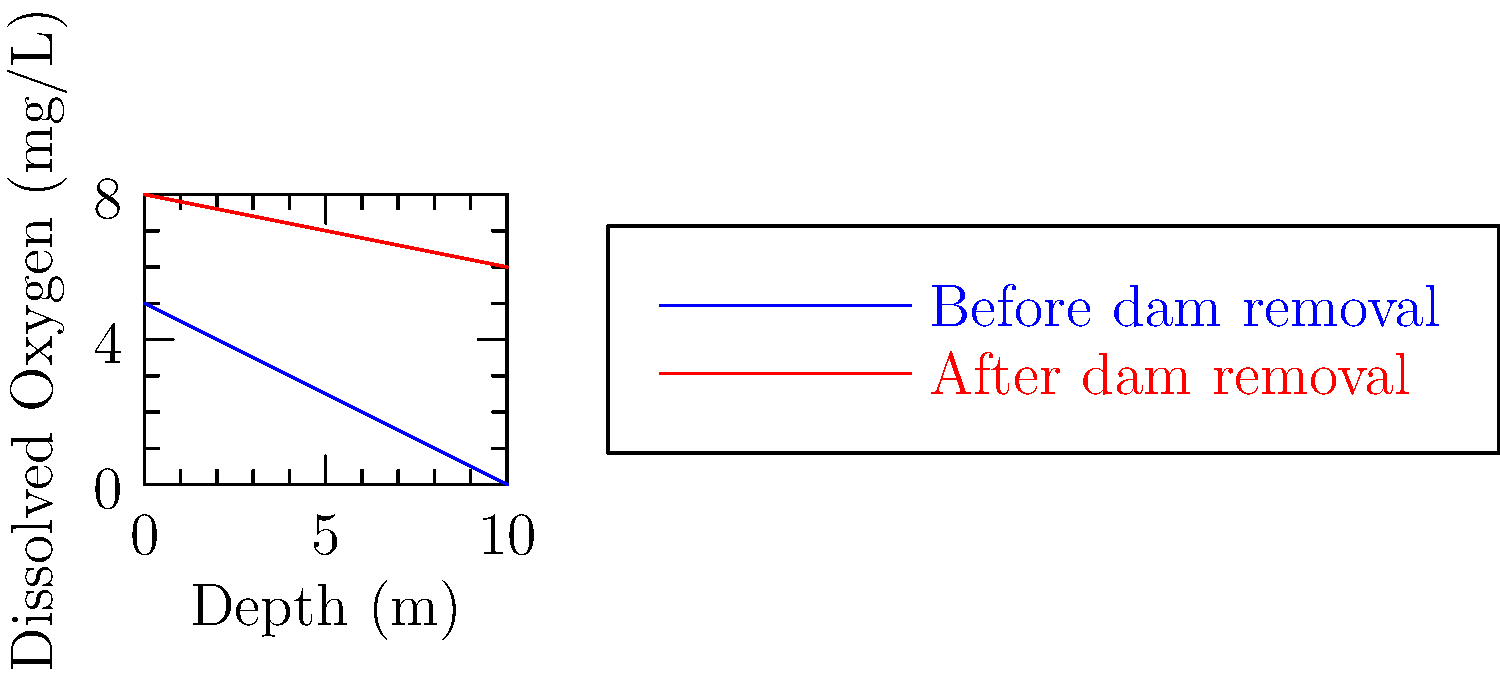The graph shows dissolved oxygen levels at different depths in a river before and after dam removal. What ecological impact does this change in oxygen distribution likely have on the river ecosystem, and why is this pattern typically observed after dam removal? 1. Observe the graph:
   - Blue line represents oxygen levels before dam removal
   - Red line represents oxygen levels after dam removal

2. Compare the slopes:
   - Before dam removal: Steeper slope, oxygen decreases more rapidly with depth
   - After dam removal: Gentler slope, oxygen decreases more slowly with depth

3. Analyze oxygen levels:
   - After dam removal, oxygen levels are higher at all depths
   - The difference is more pronounced at greater depths

4. Ecological implications:
   - Higher oxygen levels support more diverse aquatic life
   - Better oxygenation at depth expands habitable zones for fish and other organisms

5. Reasons for this pattern:
   - Dam removal restores natural river flow
   - Increased water movement and turbulence enhance oxygen mixing
   - Reduction in thermal stratification that occurs in dam reservoirs

6. Impact on ecosystem:
   - Improved conditions for oxygen-sensitive species (e.g., certain fish species)
   - Enhanced decomposition of organic matter
   - Potential increase in biodiversity and ecosystem health
Answer: Increased oxygen levels, especially at depth, likely improve habitat for aquatic organisms and enhance biodiversity. This occurs due to restored natural flow, increased water movement, and reduced thermal stratification after dam removal. 